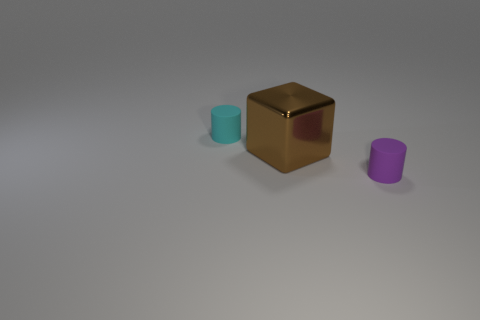Add 3 tiny cyan rubber cylinders. How many objects exist? 6 Subtract all cyan cylinders. How many cylinders are left? 1 Subtract 0 purple cubes. How many objects are left? 3 Subtract all cylinders. How many objects are left? 1 Subtract all brown metallic blocks. Subtract all large gray cubes. How many objects are left? 2 Add 2 small cyan matte objects. How many small cyan matte objects are left? 3 Add 1 brown blocks. How many brown blocks exist? 2 